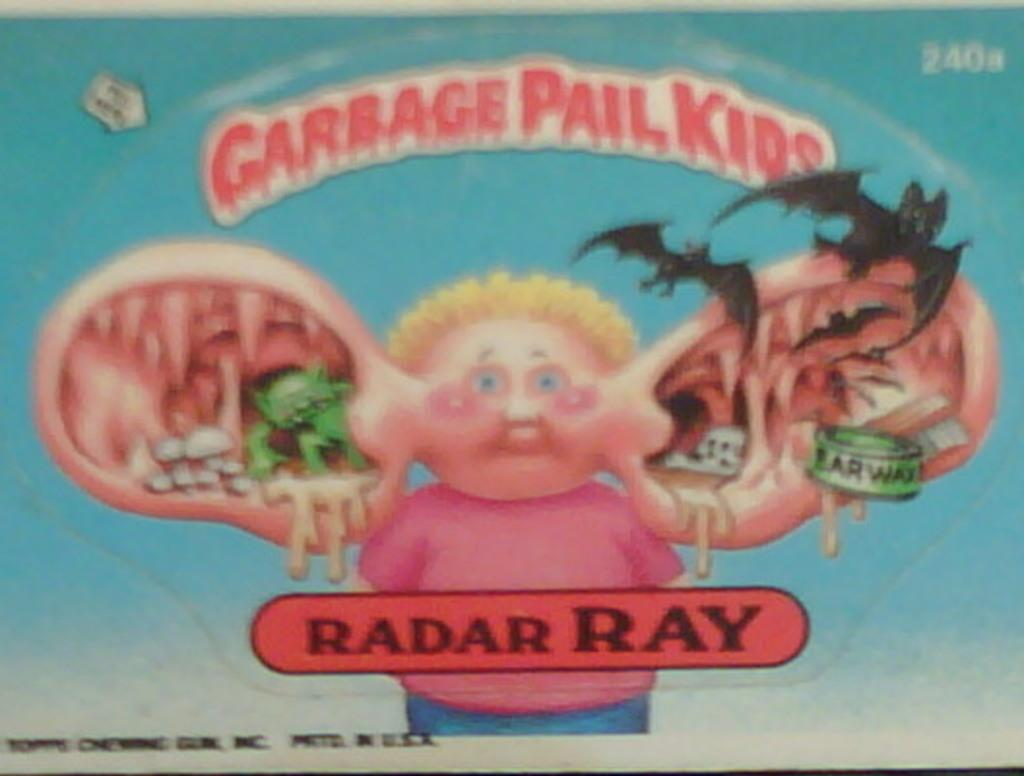<image>
Summarize the visual content of the image. The scary old cartoon is of garbage pailkids. 